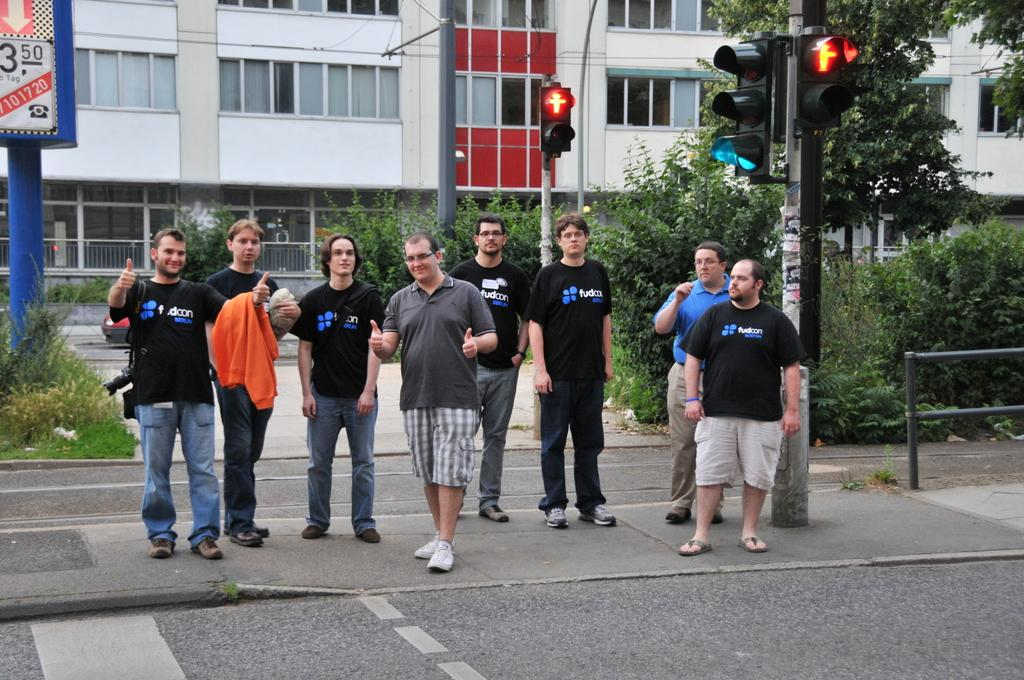What are the men in the image doing? The men in the image are standing on the footpath. What is located near the men? A traffic light is beside the men. What can be seen in the background of the image? There is a building in the background. What type of vegetation is present in front of the building? Trees are present in front of the building. What type of skirt is the traffic light wearing in the image? There is no skirt present in the image, as traffic lights do not wear clothing. What hobbies do the trees in front of the building have? Trees do not have hobbies, as they are inanimate objects. 